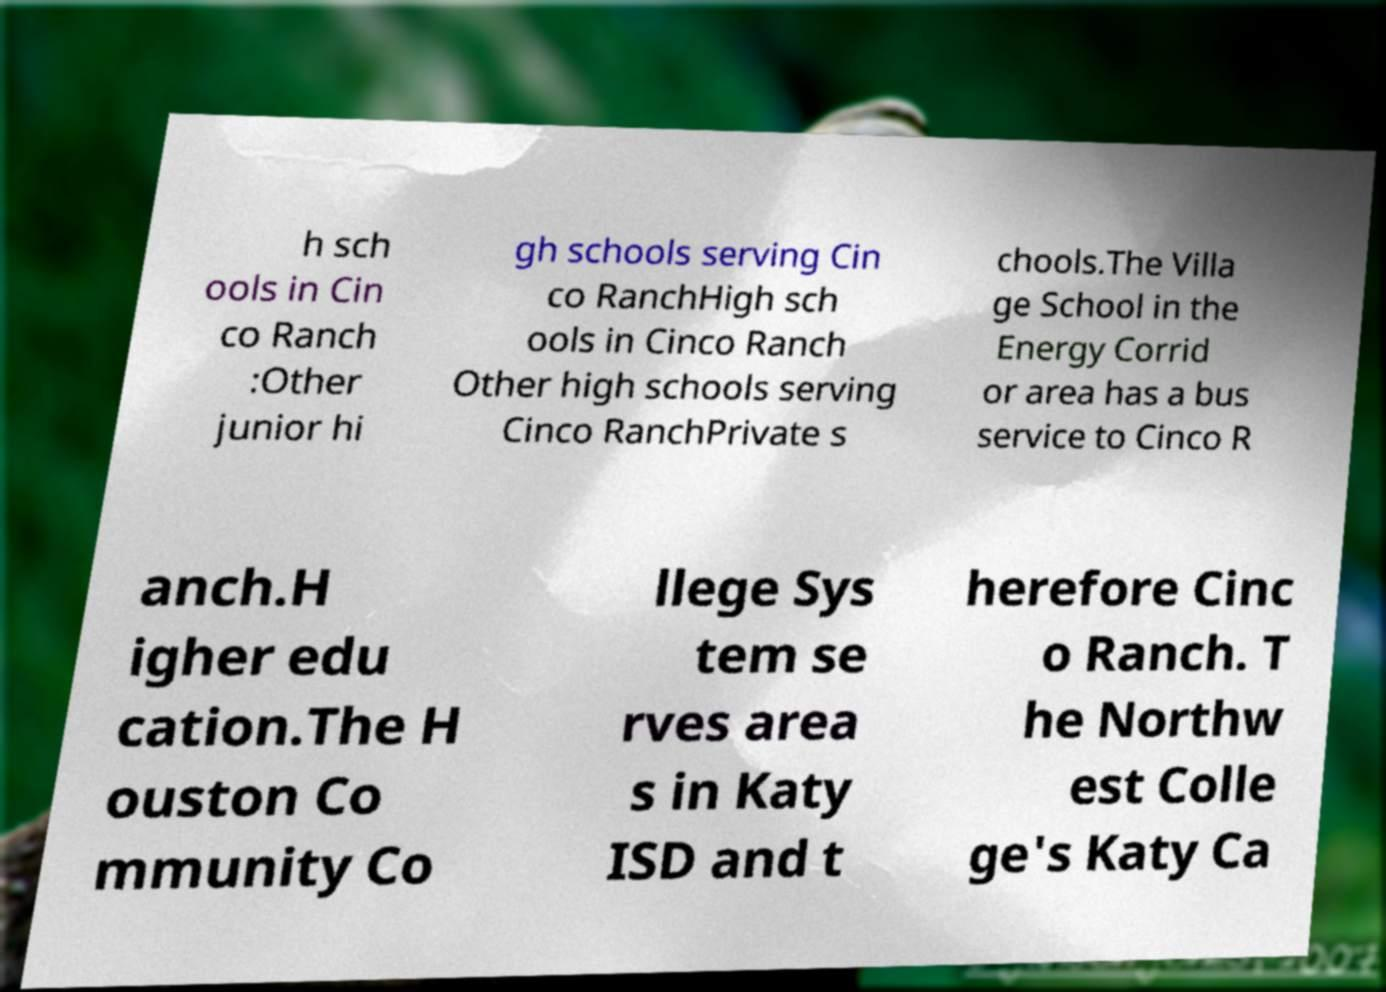Please read and relay the text visible in this image. What does it say? h sch ools in Cin co Ranch :Other junior hi gh schools serving Cin co RanchHigh sch ools in Cinco Ranch Other high schools serving Cinco RanchPrivate s chools.The Villa ge School in the Energy Corrid or area has a bus service to Cinco R anch.H igher edu cation.The H ouston Co mmunity Co llege Sys tem se rves area s in Katy ISD and t herefore Cinc o Ranch. T he Northw est Colle ge's Katy Ca 